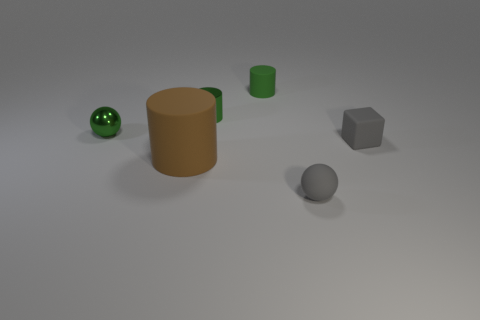Add 4 red matte spheres. How many objects exist? 10 Subtract all blocks. How many objects are left? 5 Subtract 0 yellow cubes. How many objects are left? 6 Subtract all large green blocks. Subtract all small matte blocks. How many objects are left? 5 Add 4 rubber balls. How many rubber balls are left? 5 Add 2 small metal cylinders. How many small metal cylinders exist? 3 